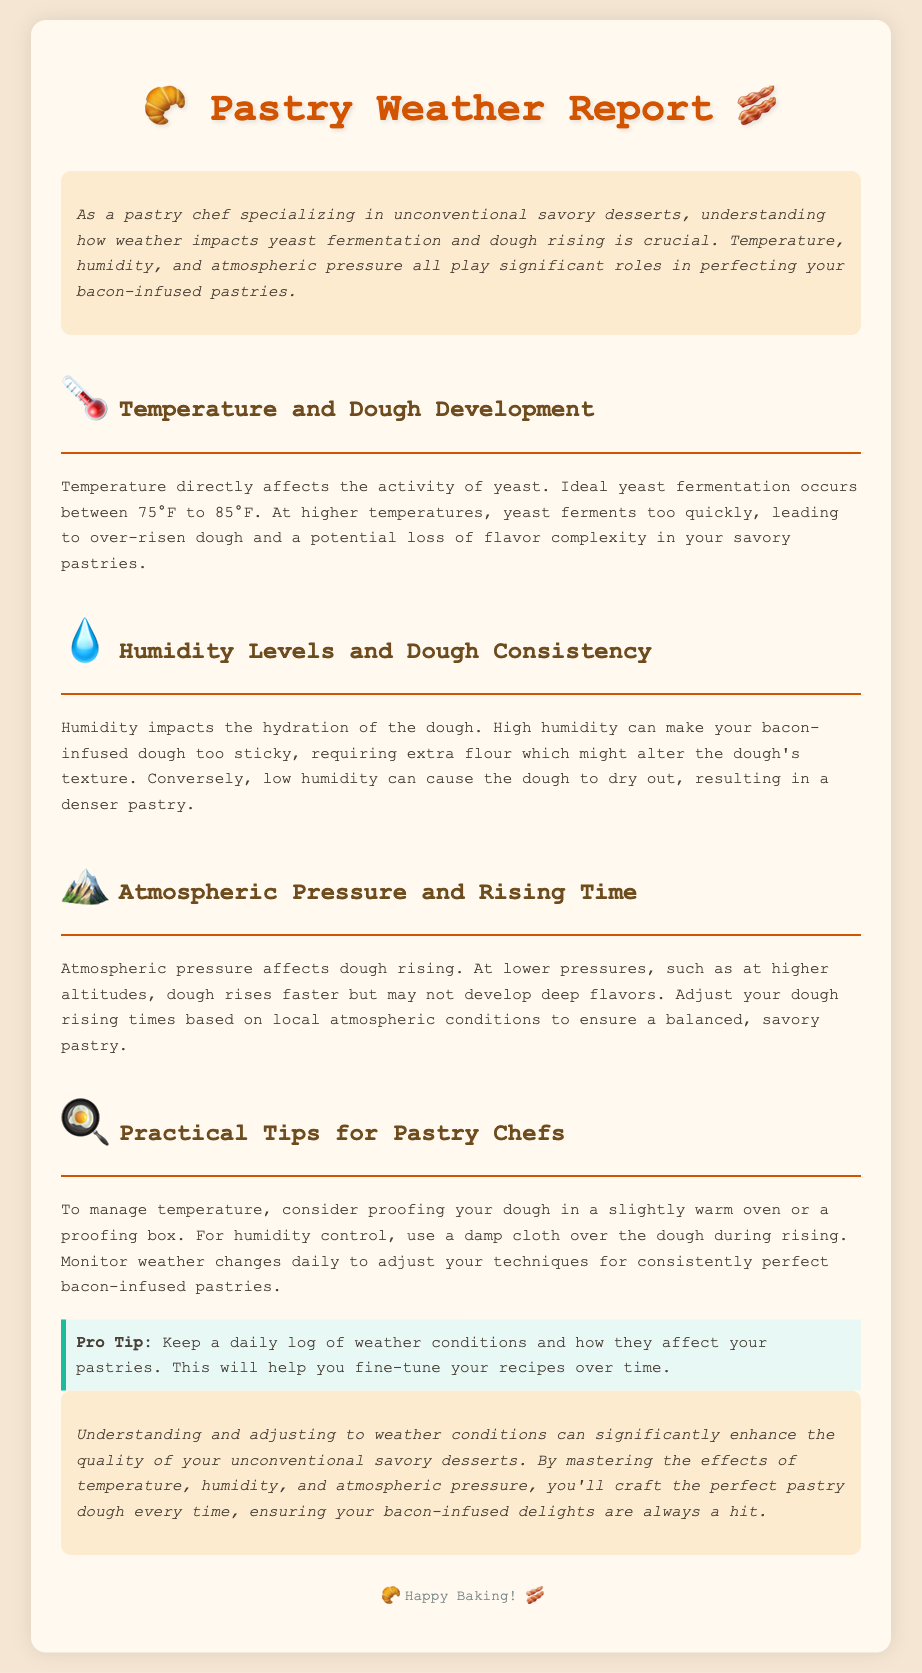What is the ideal temperature range for yeast fermentation? The ideal yeast fermentation occurs between 75°F to 85°F.
Answer: 75°F to 85°F What humidity effect can make dough too sticky? High humidity can make your bacon-infused dough too sticky.
Answer: High humidity What happens to dough at lower atmospheric pressure? At lower pressures, dough rises faster but may not develop deep flavors.
Answer: Rises faster What is a practical tip for managing dough rising due to temperature? Consider proofing your dough in a slightly warm oven or a proofing box.
Answer: Warm oven What should be used to cover dough during rising for humidity control? Use a damp cloth over the dough during rising.
Answer: Damp cloth How does low humidity affect the dough? Low humidity can cause the dough to dry out, resulting in a denser pastry.
Answer: Drier dough What is the main theme of the report? Understanding how weather impacts yeast fermentation and dough rising.
Answer: Weather impacts yeast What type of desserts does the chef specialize in? The pastry chef specializes in unconventional savory desserts.
Answer: Unconventional savory desserts Which section contains practical tips for pastry chefs? The section titled "Practical Tips for Pastry Chefs."
Answer: Practical Tips for Pastry Chefs 